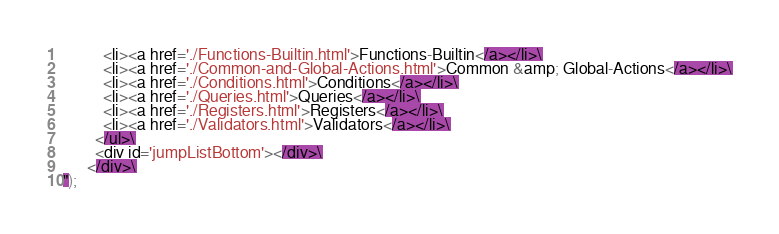Convert code to text. <code><loc_0><loc_0><loc_500><loc_500><_JavaScript_>          <li><a href='./Functions-Builtin.html'>Functions-Builtin</a></li>\
          <li><a href='./Common-and-Global-Actions.html'>Common &amp; Global-Actions</a></li>\
          <li><a href='./Conditions.html'>Conditions</a></li>\
          <li><a href='./Queries.html'>Queries</a></li>\
          <li><a href='./Registers.html'>Registers</a></li>\
          <li><a href='./Validators.html'>Validators</a></li>\
        </ul>\
        <div id='jumpListBottom'></div>\
      </div>\
");</code> 